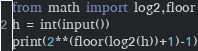Convert code to text. <code><loc_0><loc_0><loc_500><loc_500><_Python_>from math import log2,floor
h = int(input())
print(2**(floor(log2(h))+1)-1)</code> 